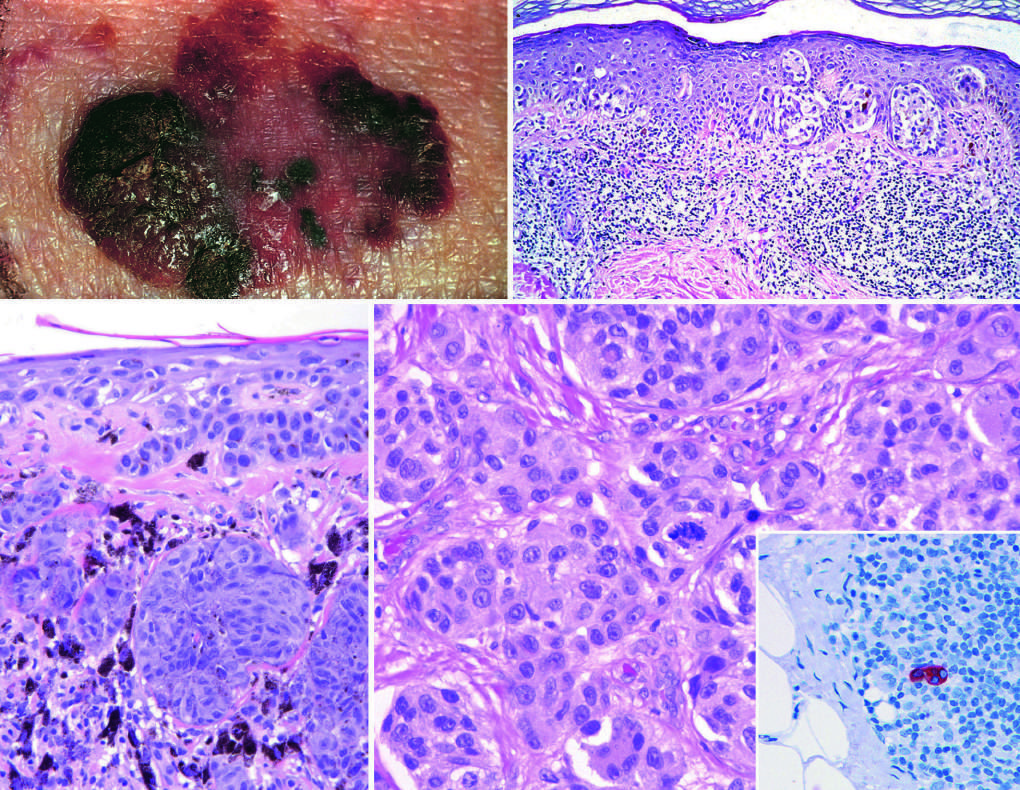do macular areas indicate superficial growth, while elevated areas indicate dermal invasion vertical growth?
Answer the question using a single word or phrase. Yes 